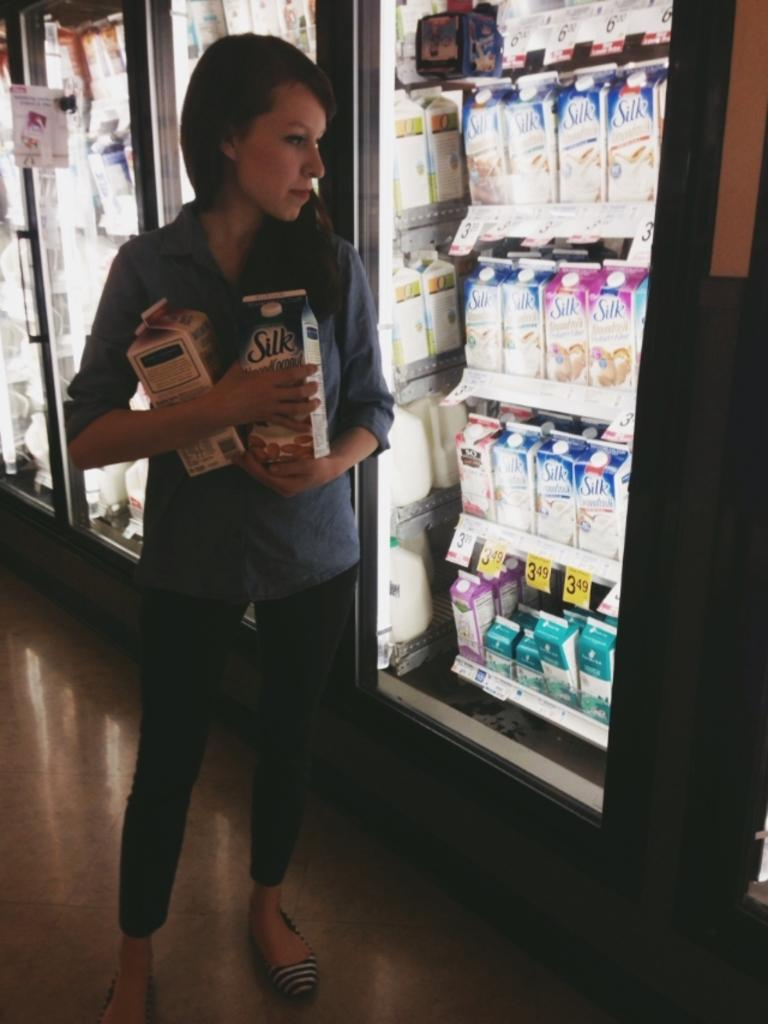<image>
Relay a brief, clear account of the picture shown. The half-gallons of Silk were priced at $3.49 and the shopper had selected two. 